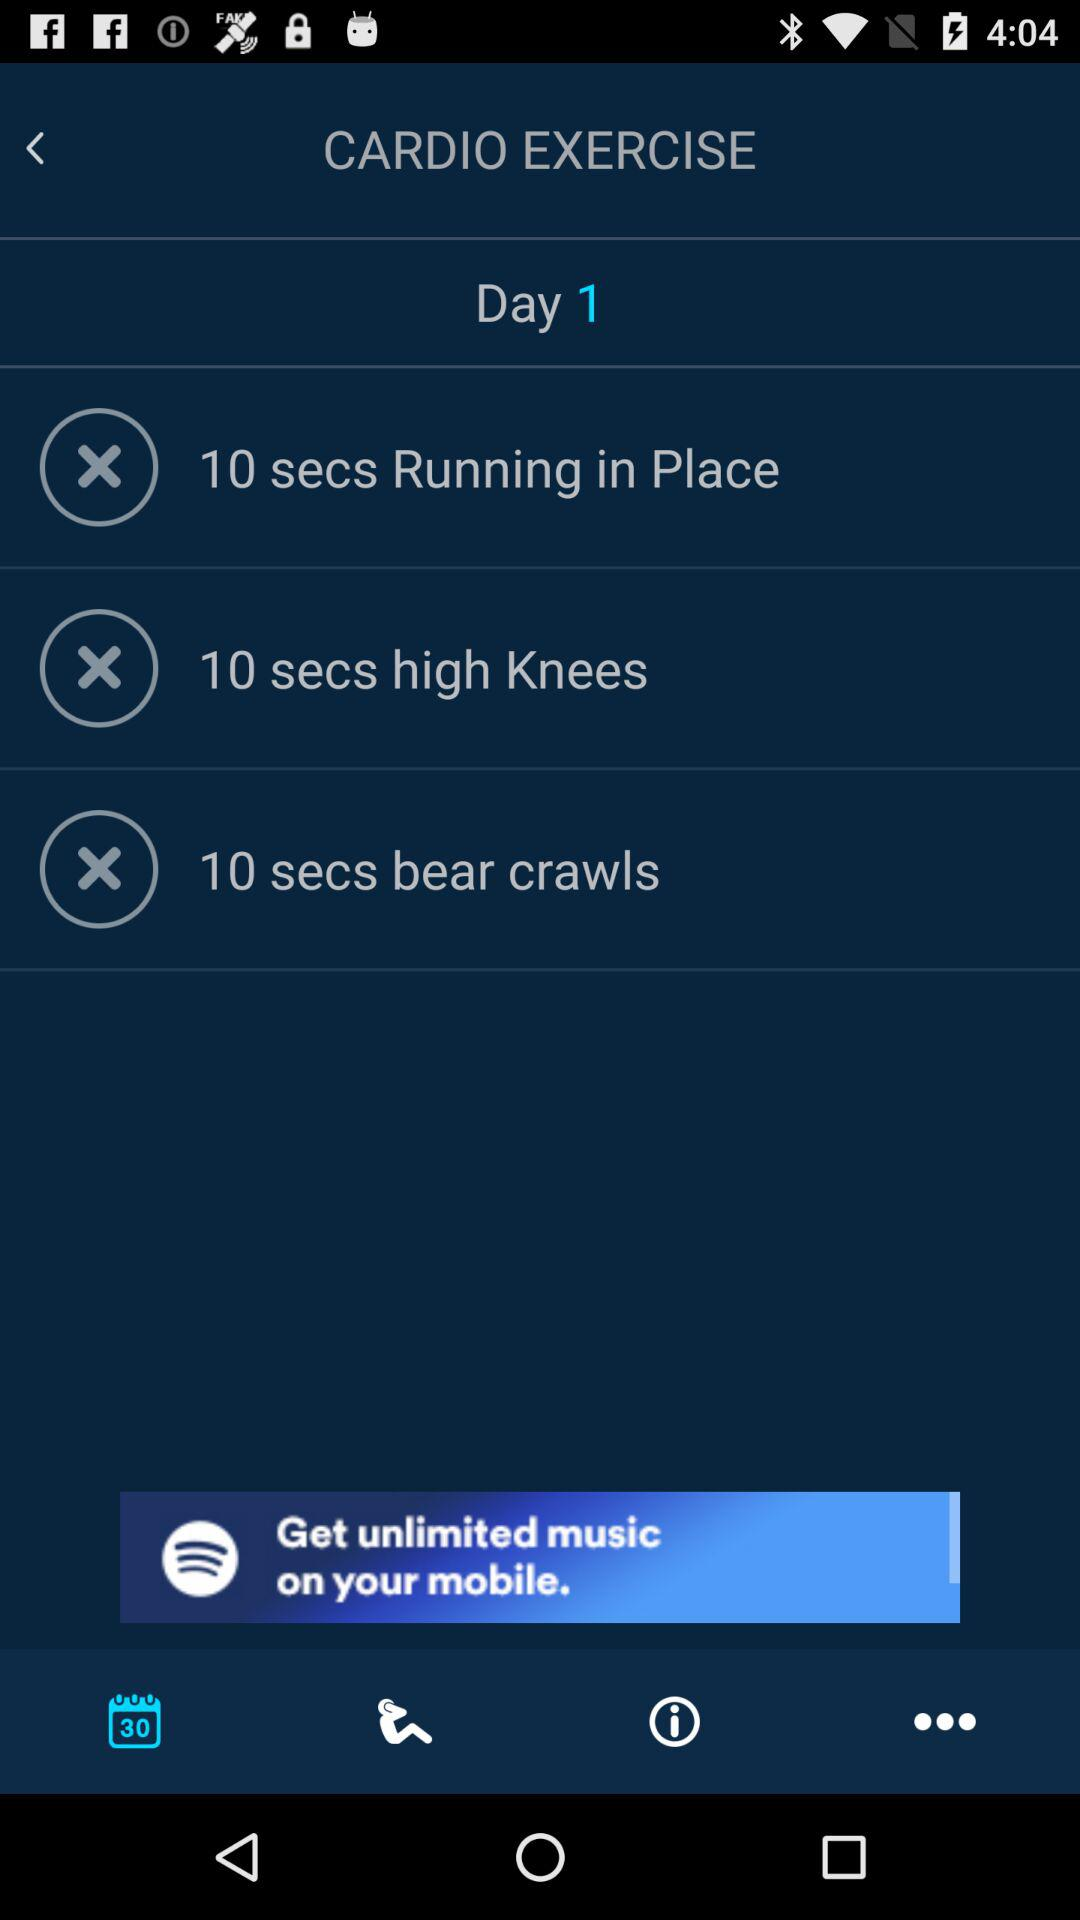Which cardio exercises are there for day 1? The cardio exercises for day 1 are "Running in Place", "high Knees" and "bear crawls". 